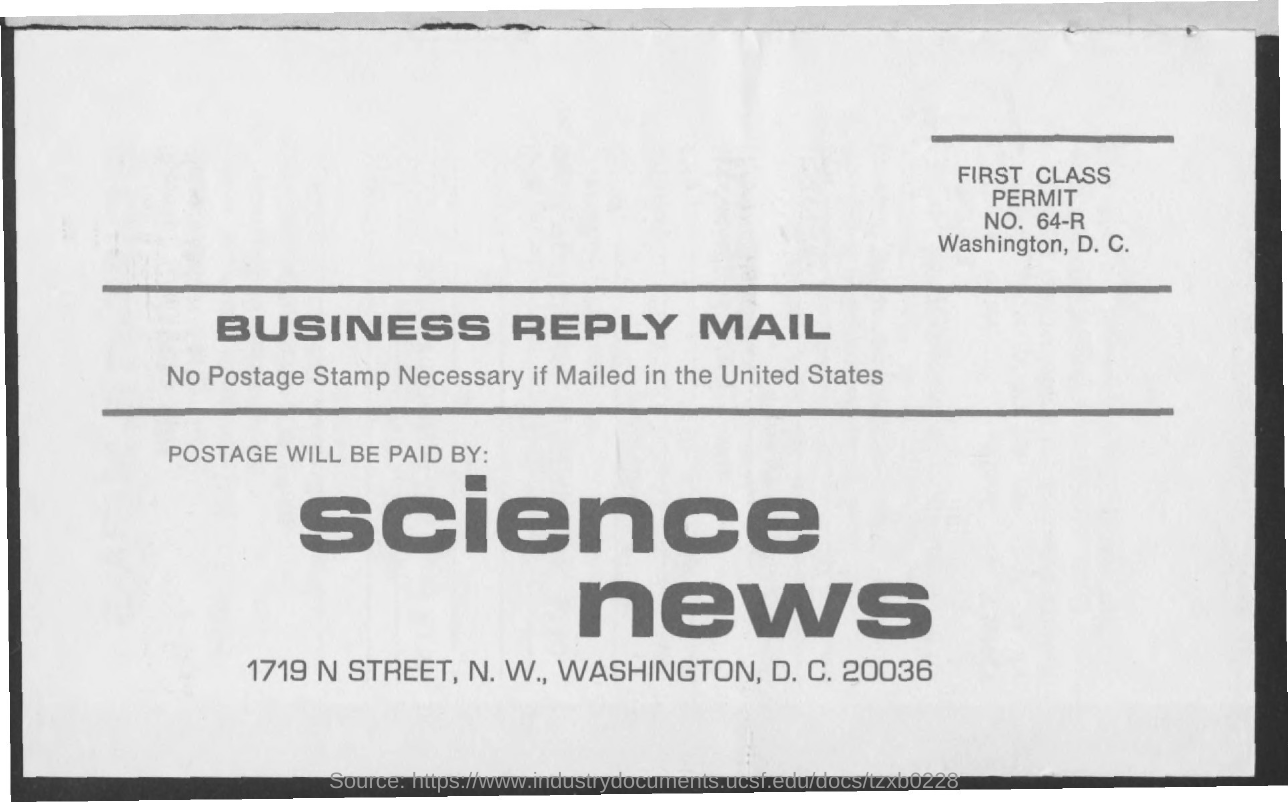Who will pay the postage?
Make the answer very short. Science News. 